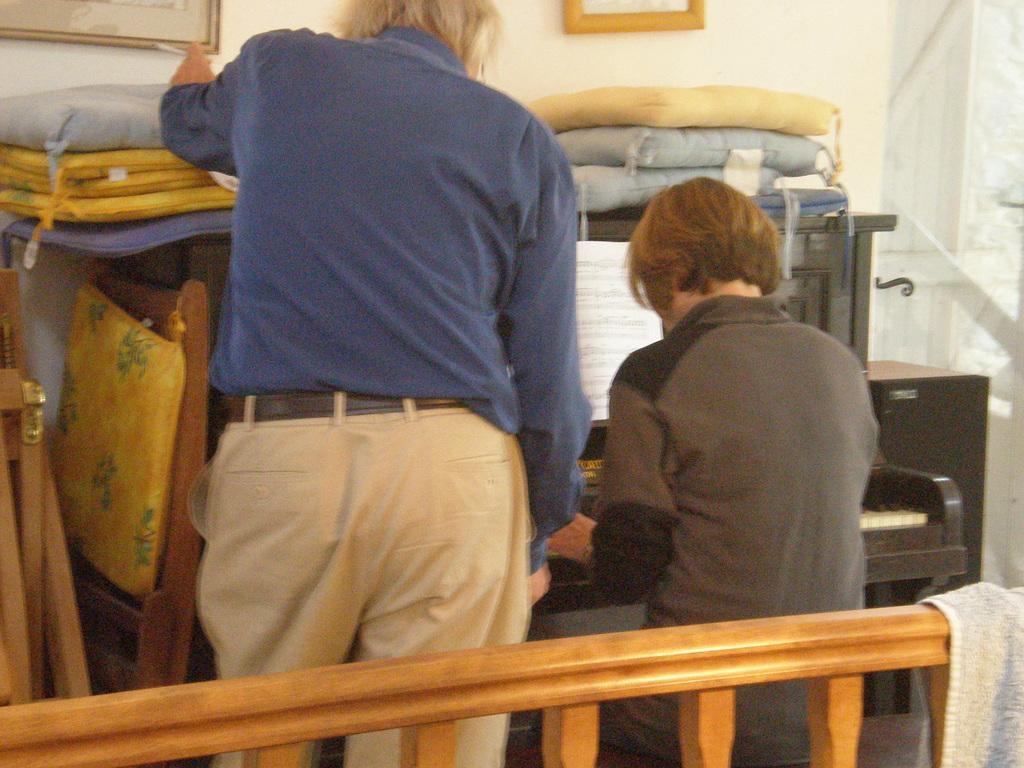Describe this image in one or two sentences. In this image we can see a person standing and the other person sitting on the chair and playing a musical instrument. In front of them, we can see a paper, table and pillows. Left side, we can see the chairs. And we can see a railing with a cloth. In the background, we can see the wall with photo frames and door. 